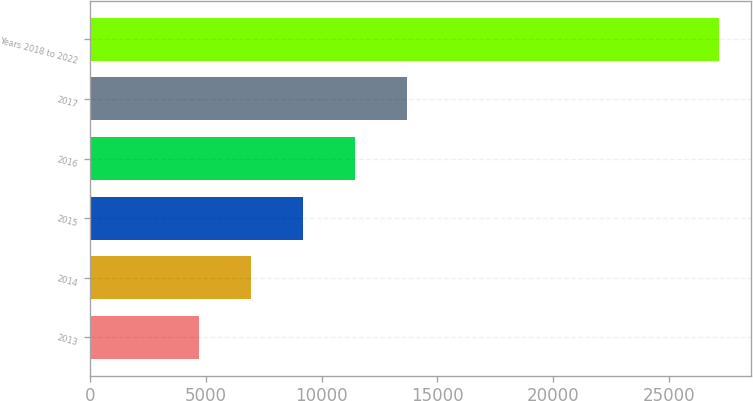Convert chart. <chart><loc_0><loc_0><loc_500><loc_500><bar_chart><fcel>2013<fcel>2014<fcel>2015<fcel>2016<fcel>2017<fcel>Years 2018 to 2022<nl><fcel>4713<fcel>6959.1<fcel>9205.2<fcel>11451.3<fcel>13697.4<fcel>27174<nl></chart> 